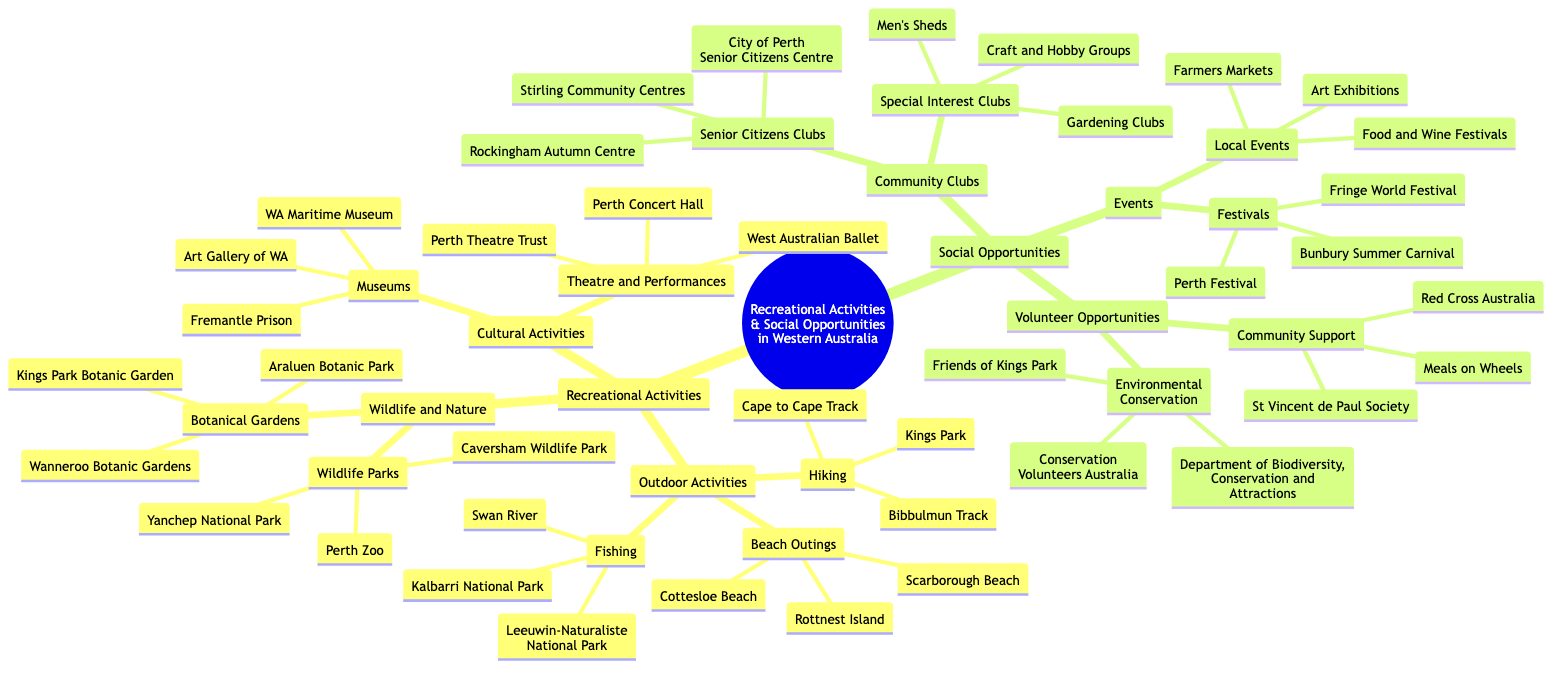What are three outdoor activities mentioned in the diagram? The diagram lists outdoor activities under "Recreational Activities". The subcategories include Hiking, Beach Outings, and Fishing. Therefore, the three outdoor activities can be directly listed from there.
Answer: Hiking, Beach Outings, Fishing Which beach is listed under Beach Outings? Under the "Beach Outings" category, the specific beaches mentioned in the diagram include Cottesloe Beach, Scarborough Beach, and Rottnest Island. Thus, any one of these can be an answer, but only one beach is being asked for.
Answer: Cottesloe Beach How many Wildlife Parks are listed? The "Wildlife and Nature" section has a subcategory for "Wildlife Parks", which includes three specific parks: Perth Zoo, Caversham Wildlife Park, and Yanchep National Park. So, counting these gives the answer.
Answer: 3 Name one event type included in Social Opportunities. The "Events" category in the "Social Opportunities" section includes subcategories of Festivals and Local Events. These are the main types of events presented in the diagram.
Answer: Festivals What organization is listed under Volunteer Opportunities for Environmental Conservation? Within the "Volunteer Opportunities" subcategory titled "Environmental Conservation", the diagram mentions Conservation Volunteers Australia as one of the organizations involved. This gives a clear and specific answer based on the diagram's information.
Answer: Conservation Volunteers Australia How many types of Community Clubs are specified? The "Community Clubs" section includes two specific types identified as "Senior Citizens Clubs" and "Special Interest Clubs". By simply counting these categories, we can find the answer.
Answer: 2 Which museum is mentioned in the Cultural Activities section? The "Cultural Activities" part includes a "Museums" subcategory, which lists WA Maritime Museum, Art Gallery of WA, and Fremantle Prison. Therefore, any one of these museums can correctly answer the question.
Answer: WA Maritime Museum How many festivals are listed? Under the "Events" category, the "Festivals" subcategory lists three specific events: Perth Festival, Fringe World Festival, and Bunbury Summer Carnival. Counting these gives the required answer.
Answer: 3 Which volunteer opportunity focuses on Community Support? The "Volunteer Opportunities" section includes a subcategory for "Community Support", listing several organizations including Meals on Wheels, Red Cross Australia, and St Vincent de Paul Society. Any one of these could be provided as the answer, and it is specifically asking for an example.
Answer: Meals on Wheels 